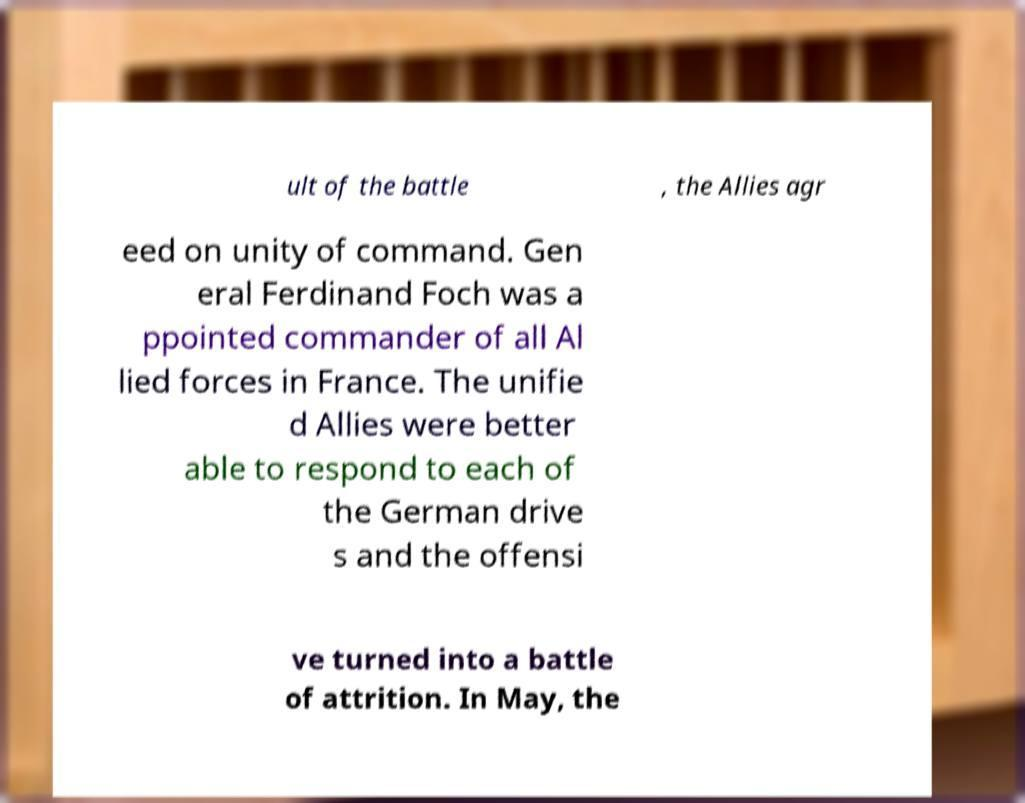Please read and relay the text visible in this image. What does it say? ult of the battle , the Allies agr eed on unity of command. Gen eral Ferdinand Foch was a ppointed commander of all Al lied forces in France. The unifie d Allies were better able to respond to each of the German drive s and the offensi ve turned into a battle of attrition. In May, the 